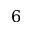Convert formula to latex. <formula><loc_0><loc_0><loc_500><loc_500>\mathsf i t { 6 }</formula> 